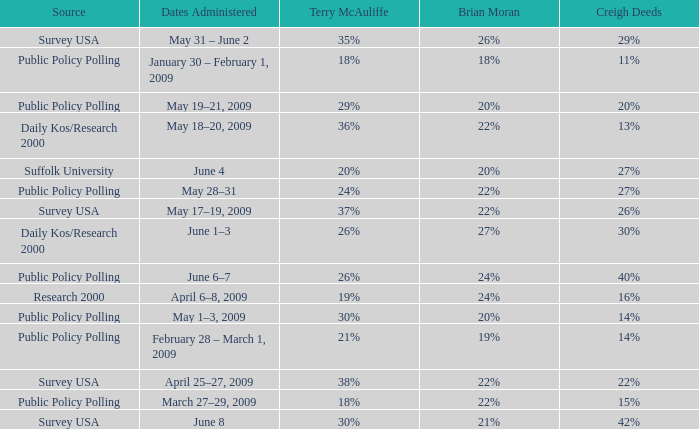Could you parse the entire table as a dict? {'header': ['Source', 'Dates Administered', 'Terry McAuliffe', 'Brian Moran', 'Creigh Deeds'], 'rows': [['Survey USA', 'May 31 – June 2', '35%', '26%', '29%'], ['Public Policy Polling', 'January 30 – February 1, 2009', '18%', '18%', '11%'], ['Public Policy Polling', 'May 19–21, 2009', '29%', '20%', '20%'], ['Daily Kos/Research 2000', 'May 18–20, 2009', '36%', '22%', '13%'], ['Suffolk University', 'June 4', '20%', '20%', '27%'], ['Public Policy Polling', 'May 28–31', '24%', '22%', '27%'], ['Survey USA', 'May 17–19, 2009', '37%', '22%', '26%'], ['Daily Kos/Research 2000', 'June 1–3', '26%', '27%', '30%'], ['Public Policy Polling', 'June 6–7', '26%', '24%', '40%'], ['Research 2000', 'April 6–8, 2009', '19%', '24%', '16%'], ['Public Policy Polling', 'May 1–3, 2009', '30%', '20%', '14%'], ['Public Policy Polling', 'February 28 – March 1, 2009', '21%', '19%', '14%'], ['Survey USA', 'April 25–27, 2009', '38%', '22%', '22%'], ['Public Policy Polling', 'March 27–29, 2009', '18%', '22%', '15%'], ['Survey USA', 'June 8', '30%', '21%', '42%']]} Which Terry McAuliffe is it that has a Dates Administered on June 6–7? 26%. 